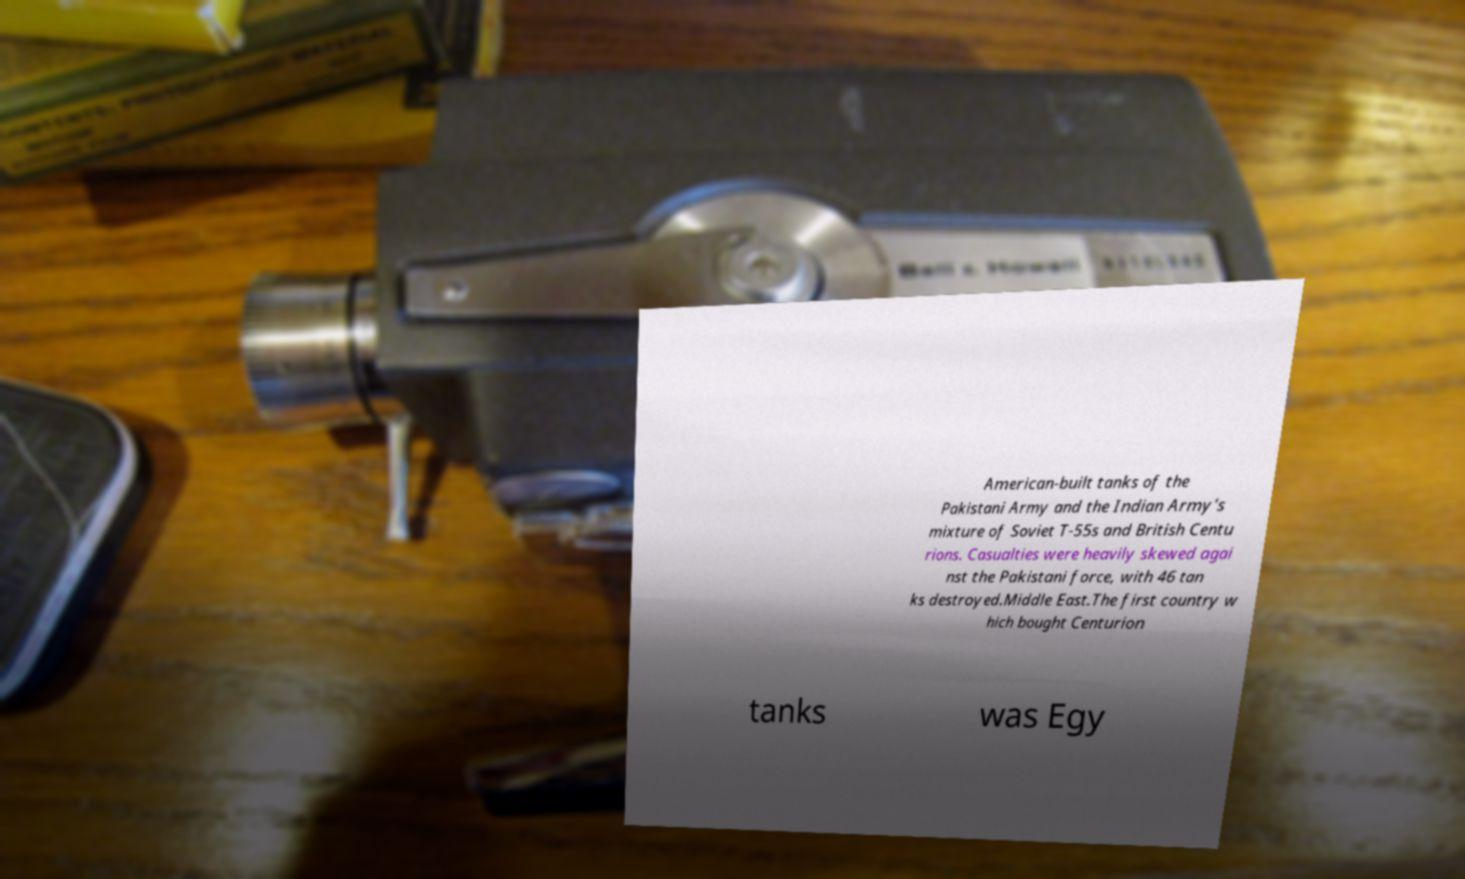Can you read and provide the text displayed in the image?This photo seems to have some interesting text. Can you extract and type it out for me? American-built tanks of the Pakistani Army and the Indian Army's mixture of Soviet T-55s and British Centu rions. Casualties were heavily skewed agai nst the Pakistani force, with 46 tan ks destroyed.Middle East.The first country w hich bought Centurion tanks was Egy 